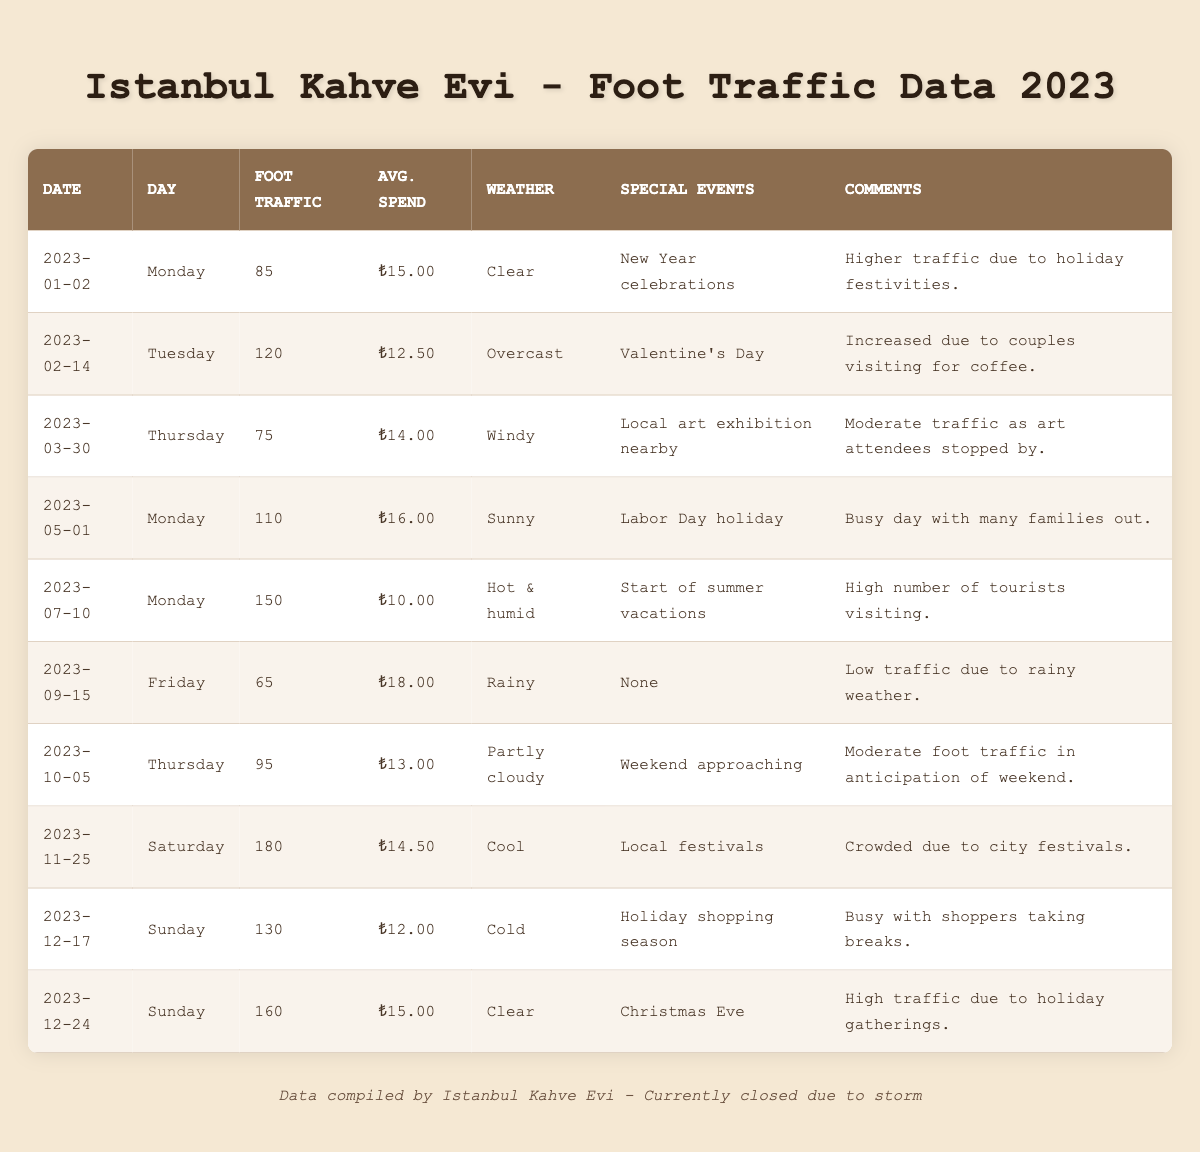What was the highest foot traffic recorded in the café for 2023? The highest foot traffic recorded is shown on the date 2023-11-25 with 180 visitors.
Answer: 180 What is the average spend per customer on 2023-05-01? According to the table, on 2023-05-01, the average spend per customer was ₺16.00.
Answer: ₺16.00 How many days had foot traffic over 100 in 2023? The days with foot traffic over 100 are 2023-02-14 (120), 2023-05-01 (110), 2023-07-10 (150), 2023-11-25 (180), 2023-12-17 (130), and 2023-12-24 (160), totaling 6 days.
Answer: 6 Was there any special event on 2023-09-15? No, there were no special events reported on 2023-09-15 according to the table.
Answer: No Which day had the lowest foot traffic and what was the weather like that day? The lowest foot traffic was on 2023-09-15 with 65 visitors, and the weather that day was rainy.
Answer: 2023-09-15, Rainy What was the average foot traffic for the summer months (June, July, and August)? The table does not explicitly list foot traffic for June and August, but we have July with 150. The average is calculated using only the July data as the other months are not available in the table.
Answer: 150 On which day did the café see an increase in foot traffic due to Valentine's Day? On 2023-02-14, foot traffic increased to 120 due to Valentine's Day.
Answer: 2023-02-14 How does the weather affect the average spend per customer? To analyze this, we observe that on rainy days (65 on 2023-09-15), the average spend was ₺18.00. In contrast, on sunny days like 2023-05-01, the average spend was ₺16.00 with higher foot traffic. Thus, weather appears to influence average spend, but the exact relationship requires more data analysis.
Answer: It's unclear without more data What is the total foot traffic for Mondays in 2023? The foot traffic for Mondays in 2023 is summed up as follows: 85 (2023-01-02) + 110 (2023-05-01) + 150 (2023-07-10) = 345, thus the total for the three Mondays listed is 345.
Answer: 345 Was the special event on 2023-11-25 significant for foot traffic? Yes, on 2023-11-25 there was a local festival, and foot traffic peaked at 180, indicating that the event significantly contributed to visitor numbers.
Answer: Yes 